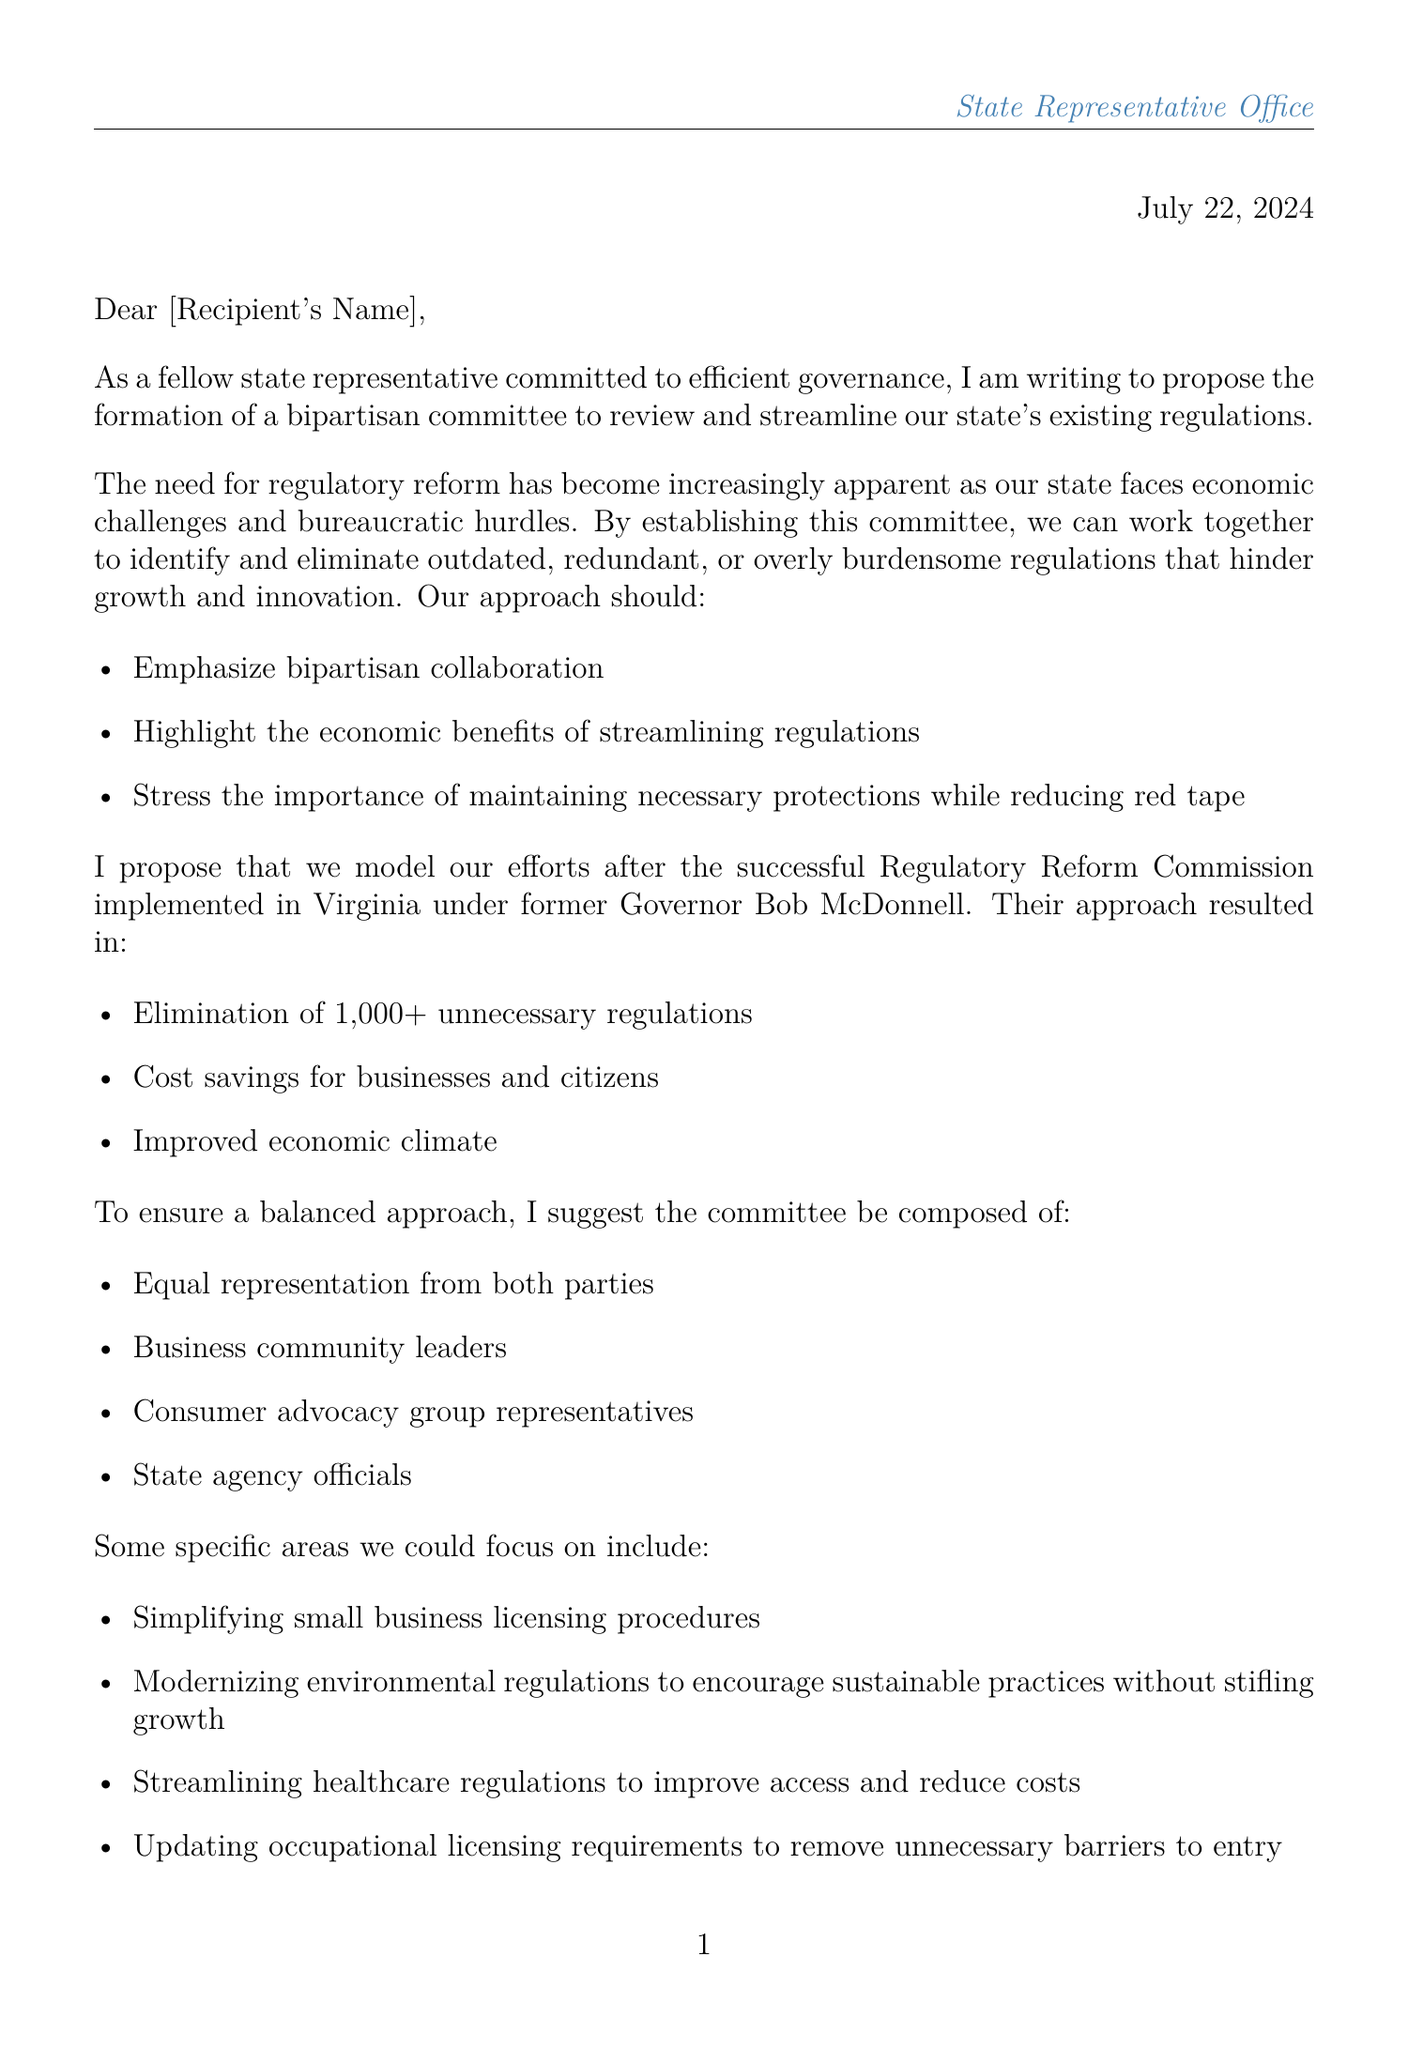What is the proposed formation in the letter? The letter proposes the formation of a bipartisan committee to review and streamline existing state regulations.
Answer: bipartisan committee Who is the model for the proposed committee based on? The proposal suggests modeling efforts after the Virginia Regulatory Reform Commission implemented under former Governor Bob McDonnell.
Answer: Virginia Regulatory Reform Commission What was the outcome of the Virginia initiative mentioned? The initiative led to the elimination of over 1,000 unnecessary regulations.
Answer: 1,000+ What are two specific areas of focus mentioned? The letter lists simplifying small business licensing procedures and modernizing environmental regulations as specific focus areas.
Answer: small business licensing procedures, environmental regulations How many parties should be equally represented in the committee? The letter states that the committee should have equal representation from both parties.
Answer: both parties What organization is referenced as a partner relevant to the proposal? The National Federation of Independent Business (NFIB) is mentioned as a potential partner.
Answer: NFIB What is one challenge faced by small businesses due to regulations? Small businesses face high annual costs of compliance with regulations, averaging $12,000 per employee.
Answer: $12,000 What is the main commitment emphasized in the conclusion? The conclusion emphasizes a commitment to limited government intervention while promoting economic stability.
Answer: limited government intervention 